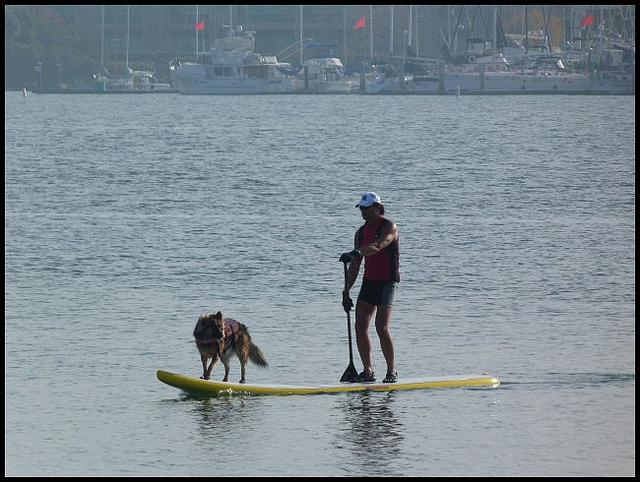What animal is riding with the man?
Short answer required. Dog. What is the dog doing?
Concise answer only. Surfing. What is the thing in the water under the man?
Give a very brief answer. Surfboard. What is the man doing?
Be succinct. Paddling. Is  this the only man on the lake?
Quick response, please. Yes. Is the man paddling?
Concise answer only. Yes. 